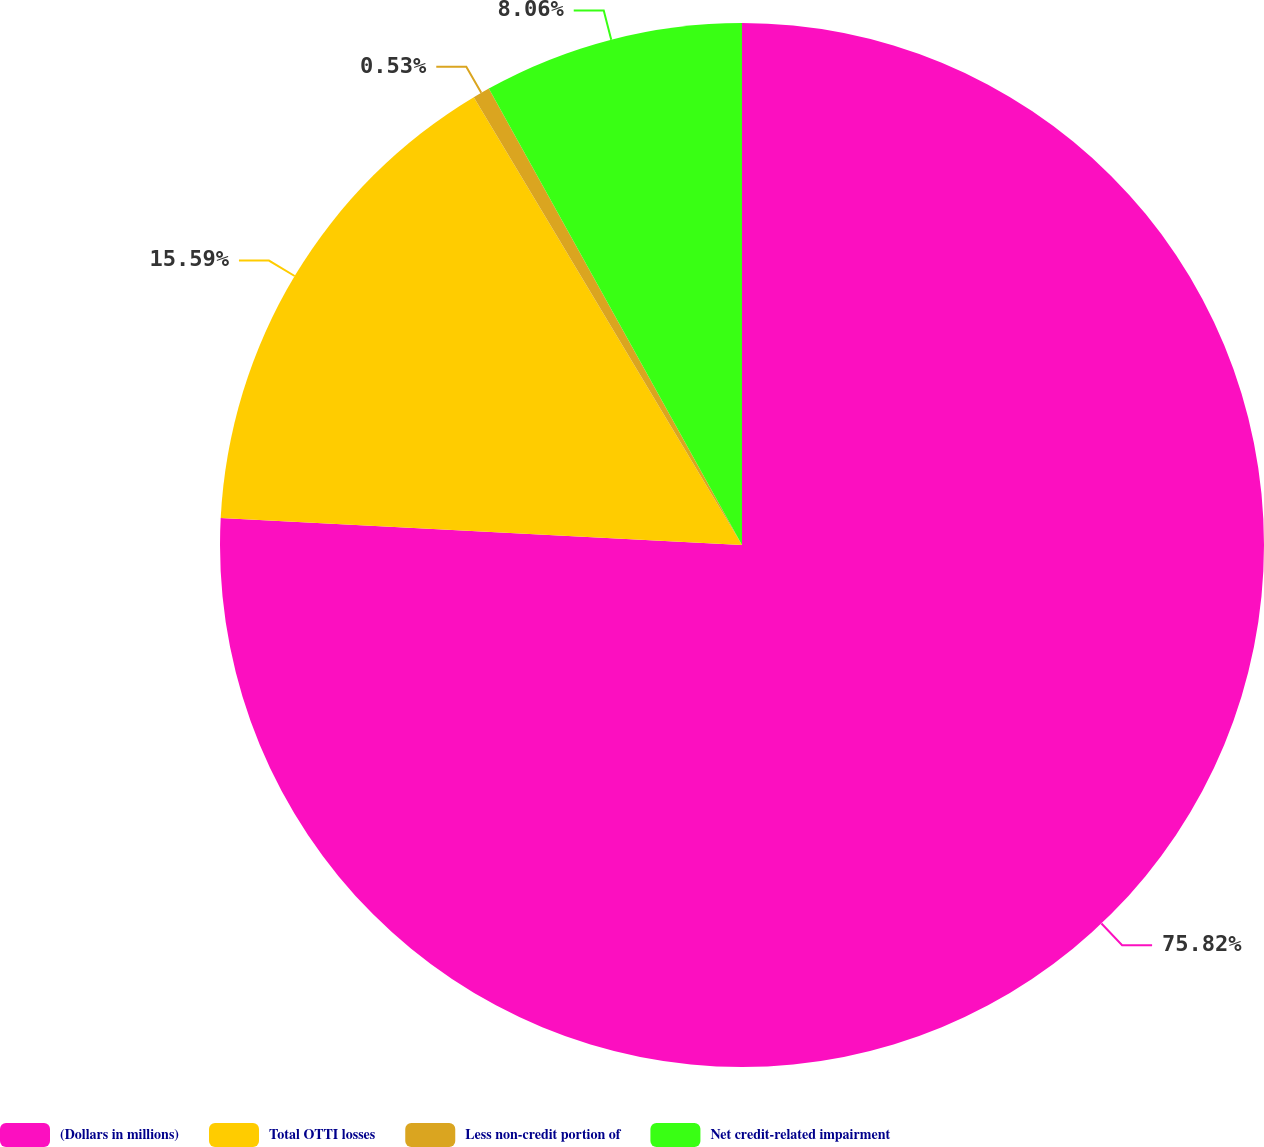<chart> <loc_0><loc_0><loc_500><loc_500><pie_chart><fcel>(Dollars in millions)<fcel>Total OTTI losses<fcel>Less non-credit portion of<fcel>Net credit-related impairment<nl><fcel>75.83%<fcel>15.59%<fcel>0.53%<fcel>8.06%<nl></chart> 